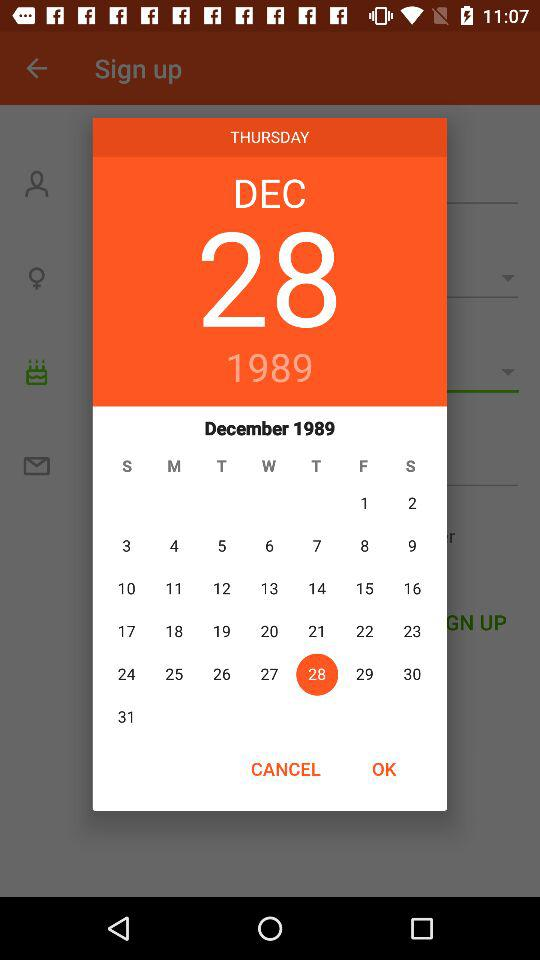What's the selected date? The selected date is Thursday, December 28, 1989. 